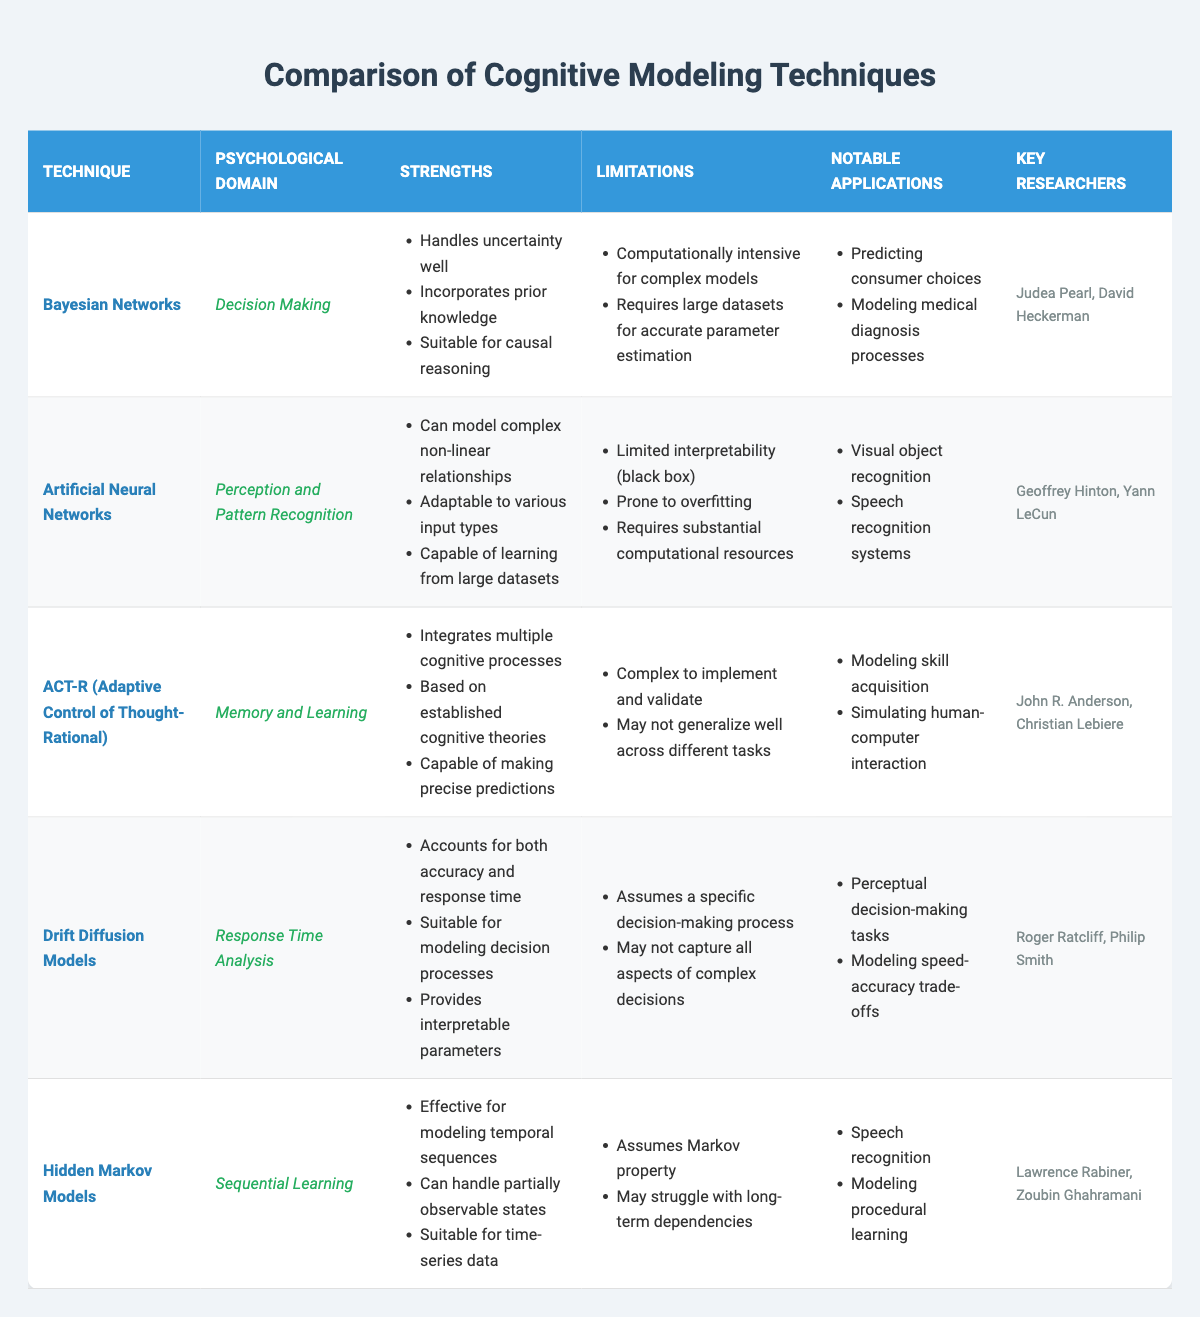What technique is associated with Response Time Analysis? From the table, we can look at the column for Psychological Domain, specifically searching for "Response Time Analysis." The technique listed there is "Drift Diffusion Models."
Answer: Drift Diffusion Models Which psychological domain has the technique capable of making precise predictions? By checking the Strengths column for each technique, the "ACT-R (Adaptive Control of Thought-Rational)" under Memory and Learning mentions it can make precise predictions, indicating that this is the relevant psychological domain.
Answer: Memory and Learning What are the notable applications of Bayesian Networks? Notable applications for Bayesian Networks are listed in the table under the 'Notable Applications' column, which includes "Predicting consumer choices" and "Modeling medical diagnosis processes."
Answer: Predicting consumer choices, Modeling medical diagnosis processes Yes or no: Does Artificial Neural Networks require large datasets for accurate results? In the Limitations column for Artificial Neural Networks, it states "Requires substantial computational resources" and does not explicitly mention large datasets for accuracy; thus, the answer is no.
Answer: No What do all techniques share in terms of limitations? To find common limitations, we examine the Limitations column for each technique. The only shared limitation among them is the tendency of some to be computationally intensive, although not all specifically mention this. Therefore, they differ in specific limitations and this statement cannot be affirmed as common to all.
Answer: No common limitation If comparing the strengths of ACT-R and Bayesian Networks, how many unique strengths do they have combined? First, we total the strengths for each technique: ACT-R has 3 strengths and Bayesian Networks has 3 strengths as well. After listing them out, there are no repeats in their strengths, leading to a total of 6 unique strengths when combined.
Answer: 6 unique strengths Who are the key researchers for Drift Diffusion Models? The Key Researchers column for Drift Diffusion Models lists "Roger Ratcliff" and "Philip Smith," providing their names as the associated researchers for this technique.
Answer: Roger Ratcliff, Philip Smith Which technique is described as computationally intensive in the limitations? Looking through the Limitations column, both Bayesian Networks and Artificial Neural Networks mention computational intensity. We can see that Bayesian Networks explicitly mentions it in the context of complex models.
Answer: Bayesian Networks What psychological domain focuses on sequential learning? Checking the Psychological Domain column, we see that "Hidden Markov Models" is listed under the domain of Sequential Learning.
Answer: Sequential Learning 